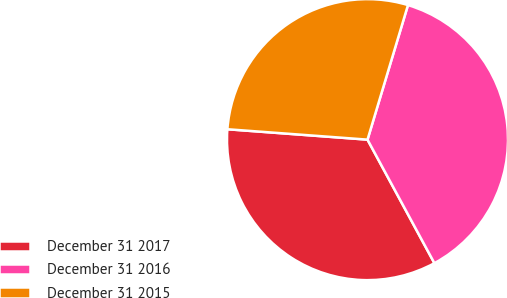Convert chart. <chart><loc_0><loc_0><loc_500><loc_500><pie_chart><fcel>December 31 2017<fcel>December 31 2016<fcel>December 31 2015<nl><fcel>34.08%<fcel>37.45%<fcel>28.47%<nl></chart> 